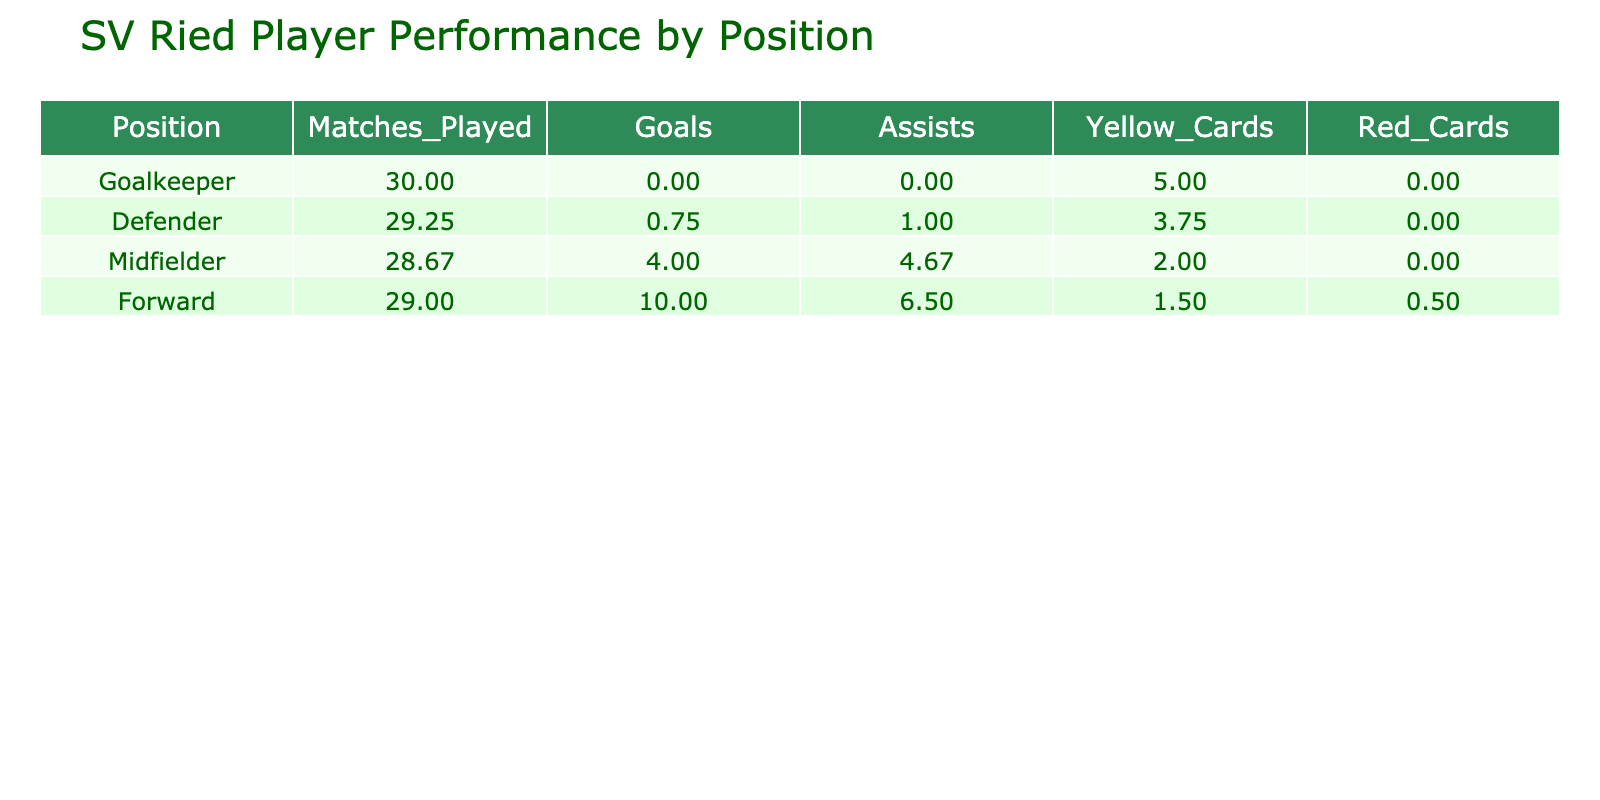What is the average number of goals scored by forwards? The goal data for forwards is as follows: Marco Grüll scored 12 goals and Sergio Oliveira scored 8 goals. To find the average, we sum the goals (12 + 8 = 20) and divide by the number of forwards (2). So, the average is 20/2 = 10.
Answer: 10 Which position has the highest average number of assists? Forwards have an average of 6.5 assists (Marco Grüll 8 and Sergio Oliveira 5), while midfielders average 4.67 assists (Ashkan Dejagah 7, Patrick Puchegger 3, and Felix Schalthofer 4). Defenders average 1 assists (Jan Kozak 1 and Michael Eberhart 1, while the others have 0), and goalkeepers have 0. The highest average is from forwards with 6.5 assists.
Answer: Forwards How many total yellow cards were received by defenders? We sum the yellow cards for all defenders: Markus Wallner 4, Michael Eberhart 6, Jan Kozak 3, and Ruben Gedo 2. The total is 4 + 6 + 3 + 2 = 15 yellow cards for defenders.
Answer: 15 Is it true that the midfielder with the most assists had also the most goals? Ashkan Dejagah is the midfielder with the most assists (7), and he also scored 5 goals. Hence, it is not the case that he has the most goals since Marco Grüll, a forward, scored the most goals (12).
Answer: No What is the difference in average matches played between defenders and midfielders? The average matches played for defenders is 29.25 (30, 28, 29, and 30) and for midfielders is 28.67 (30, 30, and 26). The difference is then calculated as 29.25 - 28.67 = 0.58 matches.
Answer: 0.58 